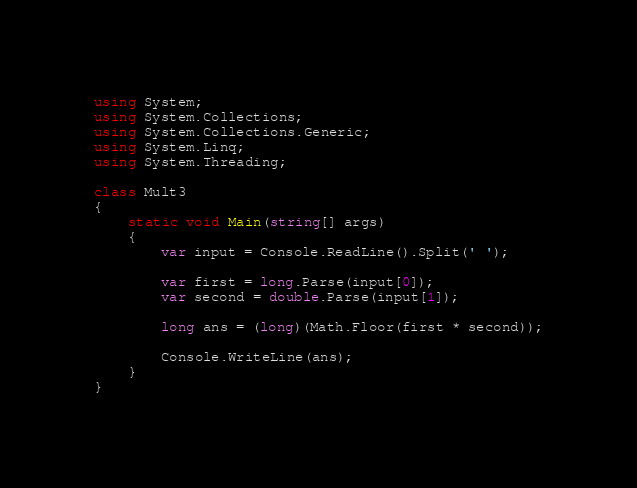Convert code to text. <code><loc_0><loc_0><loc_500><loc_500><_C#_>using System;
using System.Collections;
using System.Collections.Generic;
using System.Linq;
using System.Threading;

class Mult3
{
    static void Main(string[] args)
    {
        var input = Console.ReadLine().Split(' ');

        var first = long.Parse(input[0]);
        var second = double.Parse(input[1]);

        long ans = (long)(Math.Floor(first * second));

        Console.WriteLine(ans);
    }
}</code> 